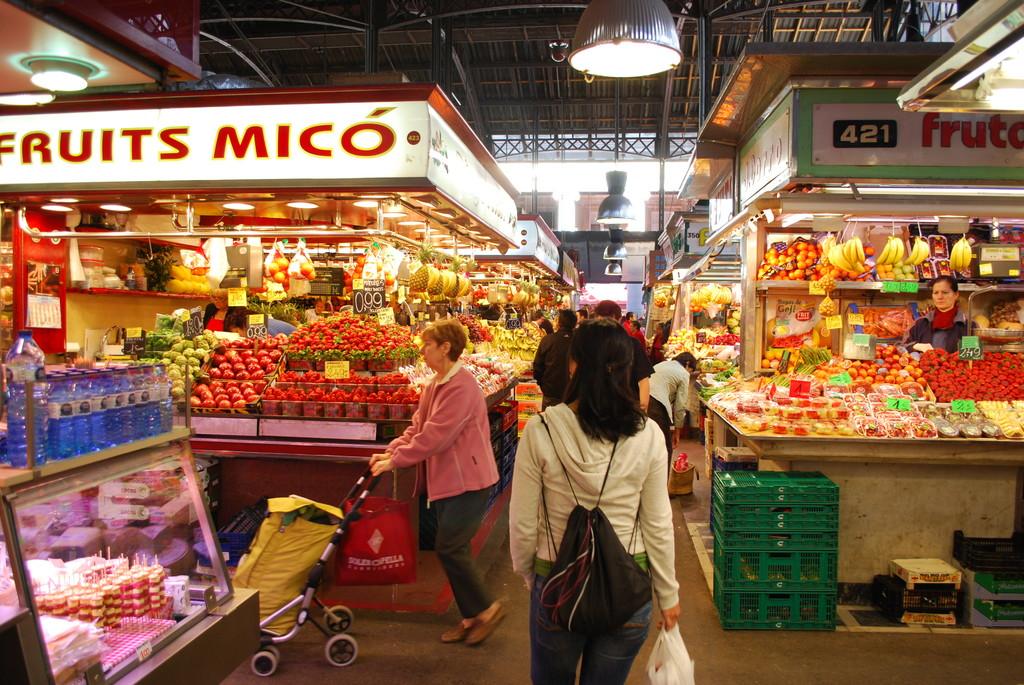Is 421 the booth number?
Offer a terse response. Yes. What does the store sell?
Keep it short and to the point. Fruits. 